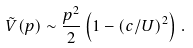Convert formula to latex. <formula><loc_0><loc_0><loc_500><loc_500>\tilde { V } ( p ) \sim \frac { p ^ { 2 } } { 2 } \left ( 1 - ( c / U ) ^ { 2 } \right ) \, .</formula> 